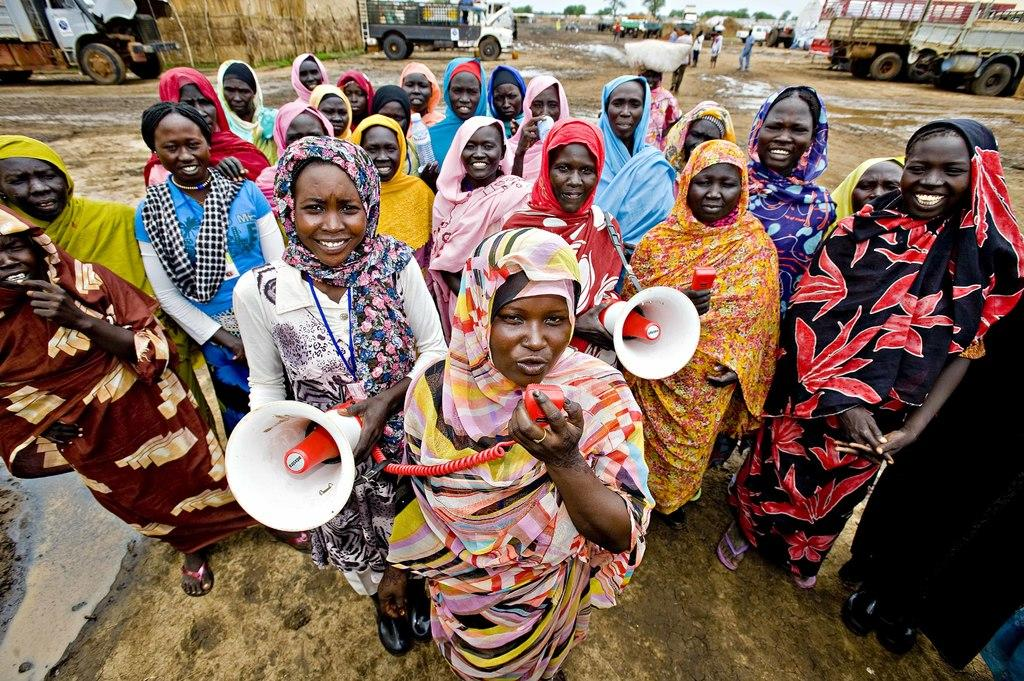How many people are the people in the image are interacting with each other? Two people are holding speakers in the image. What can be seen in the background of the image? There are vehicles, people, the ground, trees, and the sky visible in the background of the image. What might be the purpose of the speakers being held by the two people? The speakers might be used for amplifying sound during an event or performance. What type of apparel is the tramp wearing in the image? There is no tramp present in the image, so it is not possible to determine the type of apparel they might be wearing. What color is the paint on the vehicles in the background of the image? The provided facts do not mention the color of the vehicles or any paint on them, so it cannot be determined from the image. 